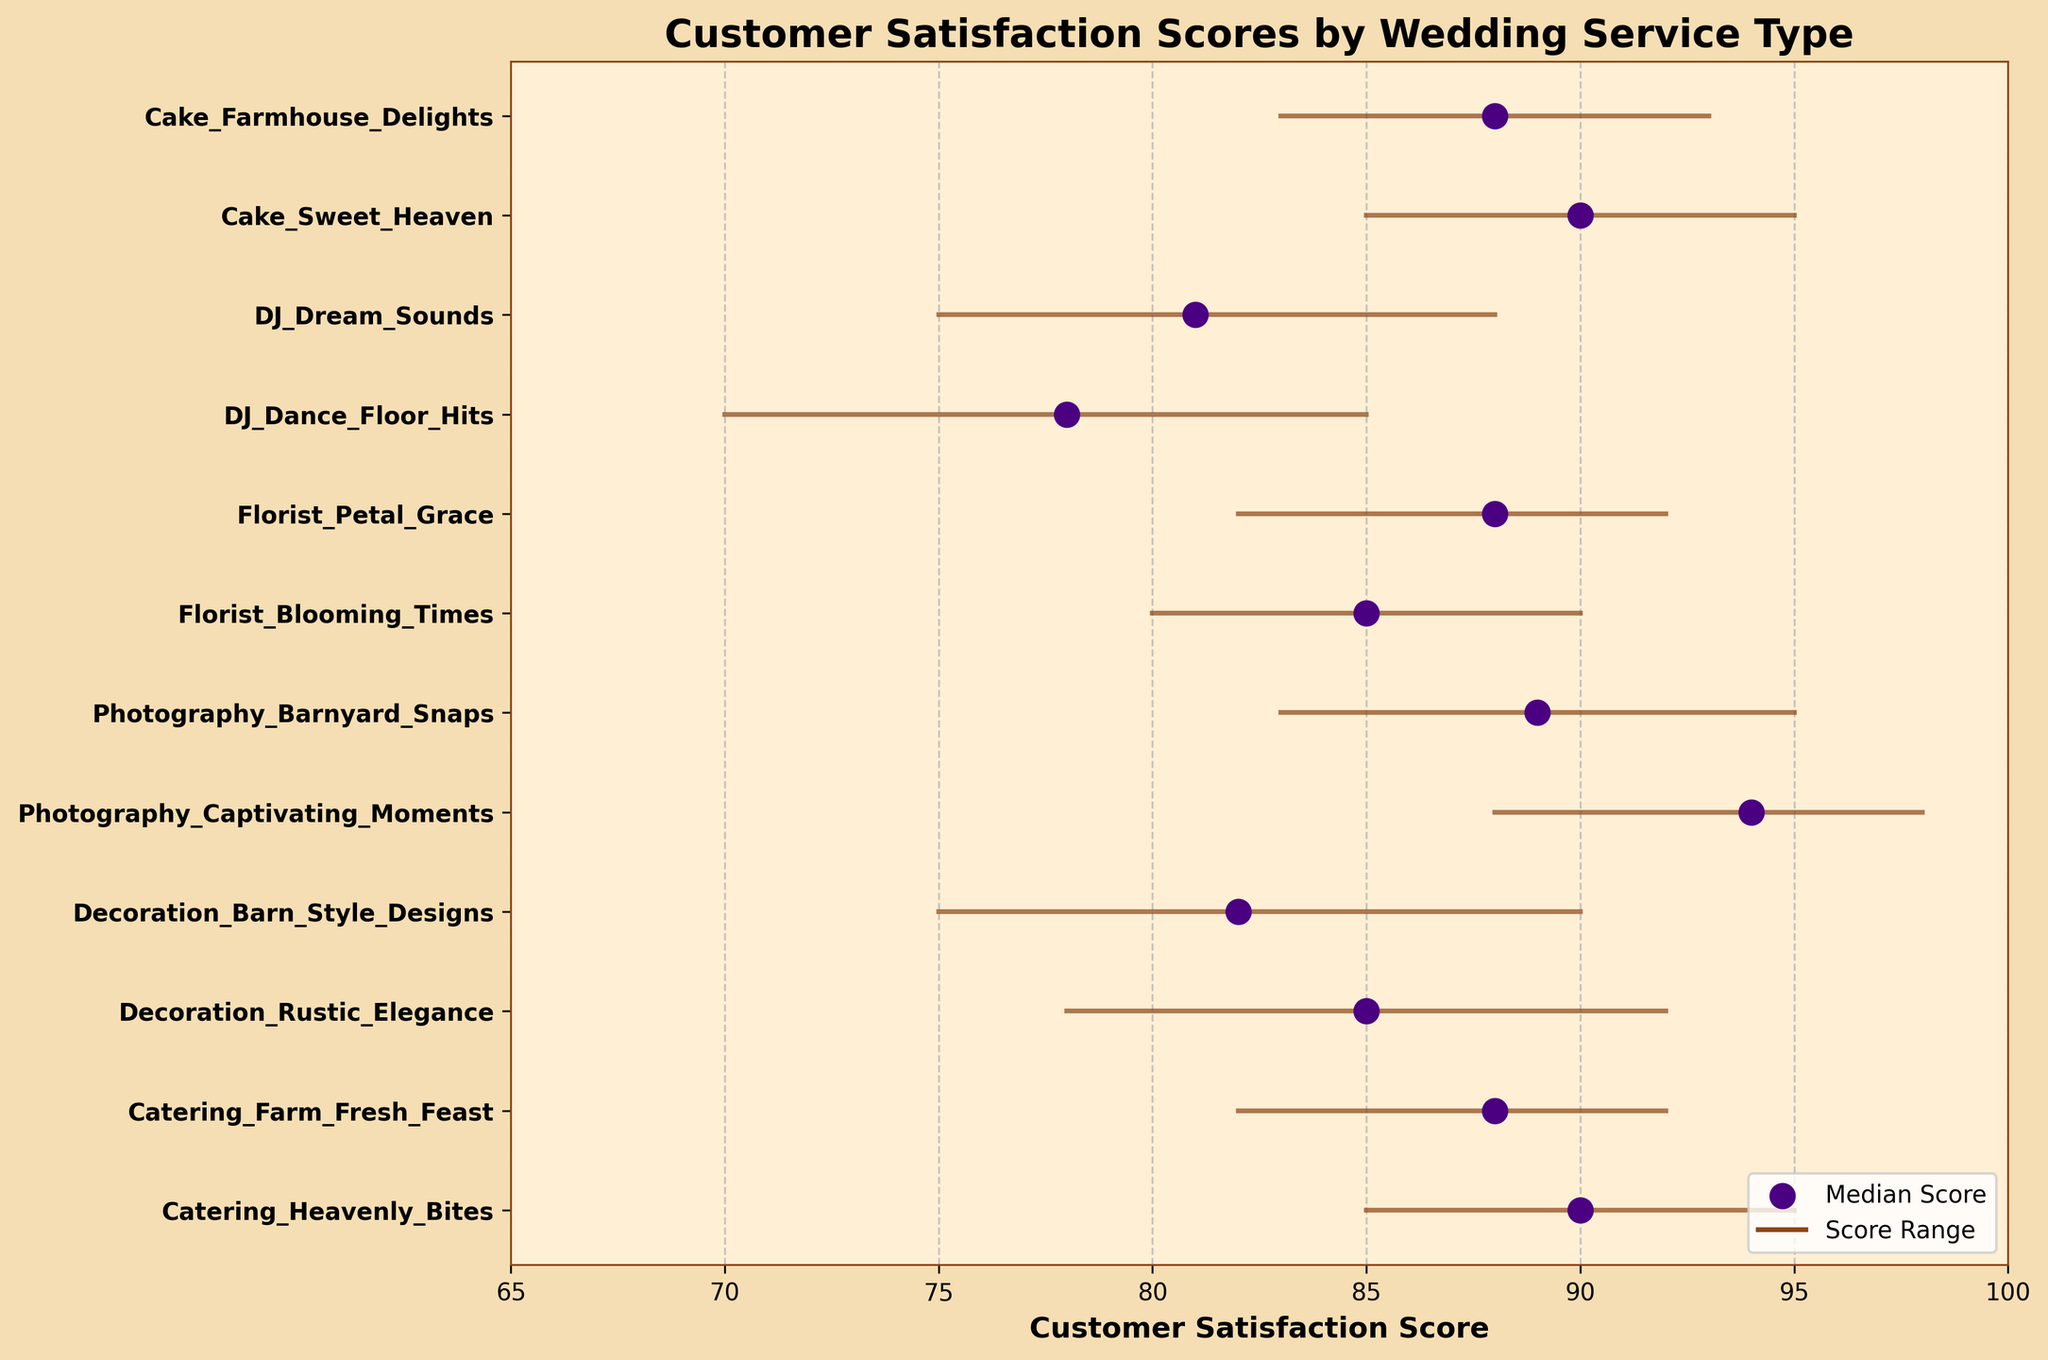Which service has the highest median satisfaction score? To find the service with the highest median satisfaction score, observe the scattered median points and identify the one with the highest value. The highest median score belongs to Photography_Captivating_Moments with a score of 94.
Answer: Photography_Captivating_Moments Which DJ service has the higher maximum satisfaction score? Look at the maximum scores for the DJ services. DJ_Dance_Floor_Hits has a maximum score of 85 whereas DJ_Dream_Sounds has 88, so DJ_Dream_Sounds has the higher maximum satisfaction score.
Answer: DJ_Dream_Sounds What is the range of customer satisfaction scores for Cake_Sweet_Heaven? The range is calculated by subtracting the minimum score from the maximum score. For Cake_Sweet_Heaven, it is 95 - 85 = 10.
Answer: 10 Between which two services is the difference in median satisfaction scores the smallest? Compare the median scores of all the services and determine the smallest difference. The smallest difference is between Catering_Farm_Fresh_Feast and Florist_Petal_Grace, both have a median score of 88.
Answer: Catering_Farm_Fresh_Feast and Florist_Petal_Grace What is the average of the median satisfaction scores for the Decorating services? The median scores for Decorating services are 85 for Rustic_Elegance and 82 for Barn_Style_Designs. To find the average, add the median scores and divide by 2: (85 + 82) / 2 = 83.5.
Answer: 83.5 Which service type overall has the highest minimum satisfaction score? Look at the minimum scores across all services and identify the highest value. Photography_Captivating_Moments has the highest minimum score of 88.
Answer: Photography_Captivating_Moments Is the satisfaction score range for Catering_Heavenly_Bites wider than for DJ_Dream_Sounds? Calculate the score ranges: Catering_Heavenly_Bites range is 95 - 85 = 10, DJ_Dream_Sounds range is 88 - 75 = 13. The range for DJ_Dream_Sounds is wider.
Answer: No Which service has the lowest satisfaction score range? Find the service with the smallest difference between the maximum and minimum scores. The lowest range is DJ_Dance_Floor_Hits with a range of 85 - 70 = 15.
Answer: DJ_Dance_Floor_Hits 